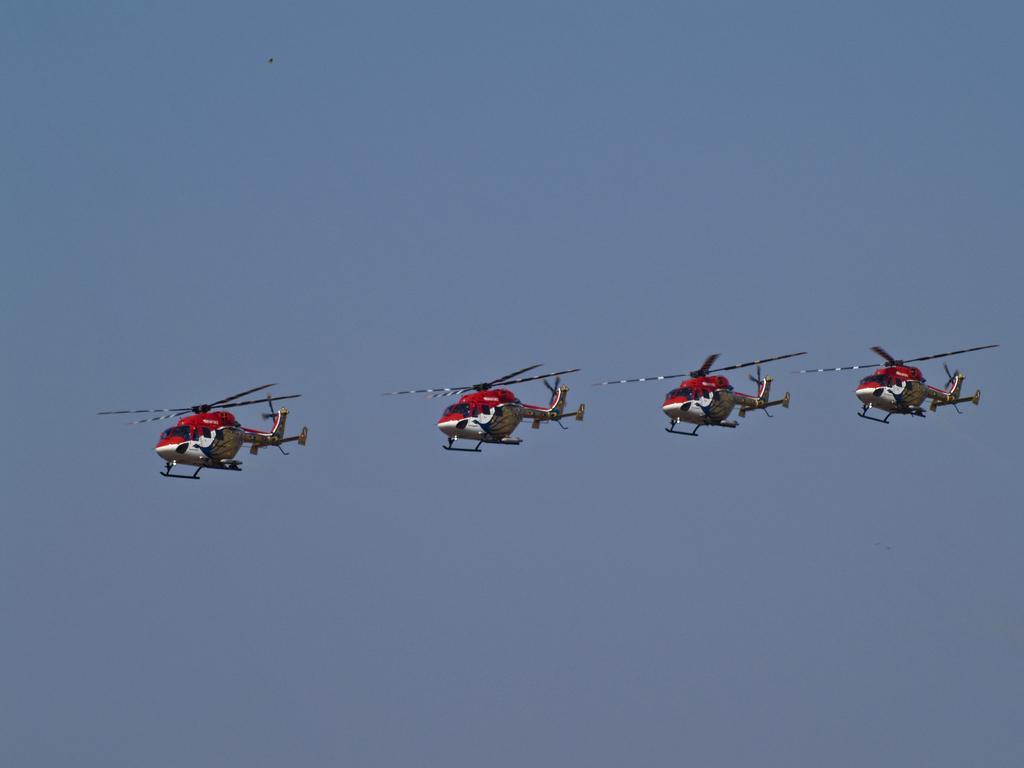Describe this image in one or two sentences. In this image, I can see four helicopters flying in the sky. The sky looks light blue in color. 